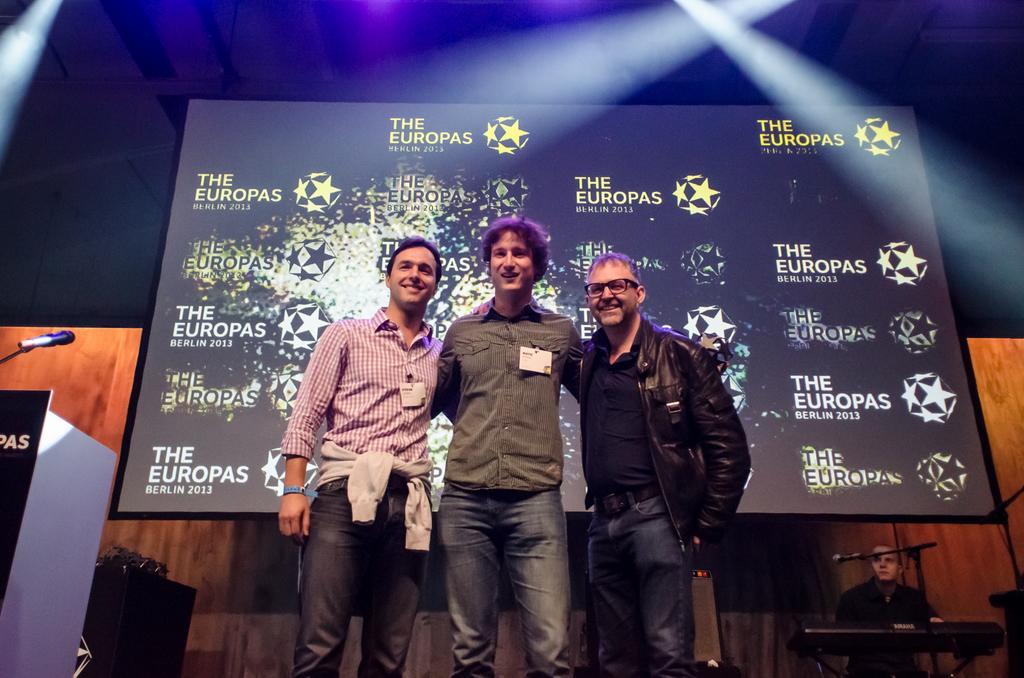Please provide a concise description of this image. This image consists of three men standing on the dais. To the left, there is a podium along with the mic. In the background, there is a screen. To the right, there is a man playing keyboard. 